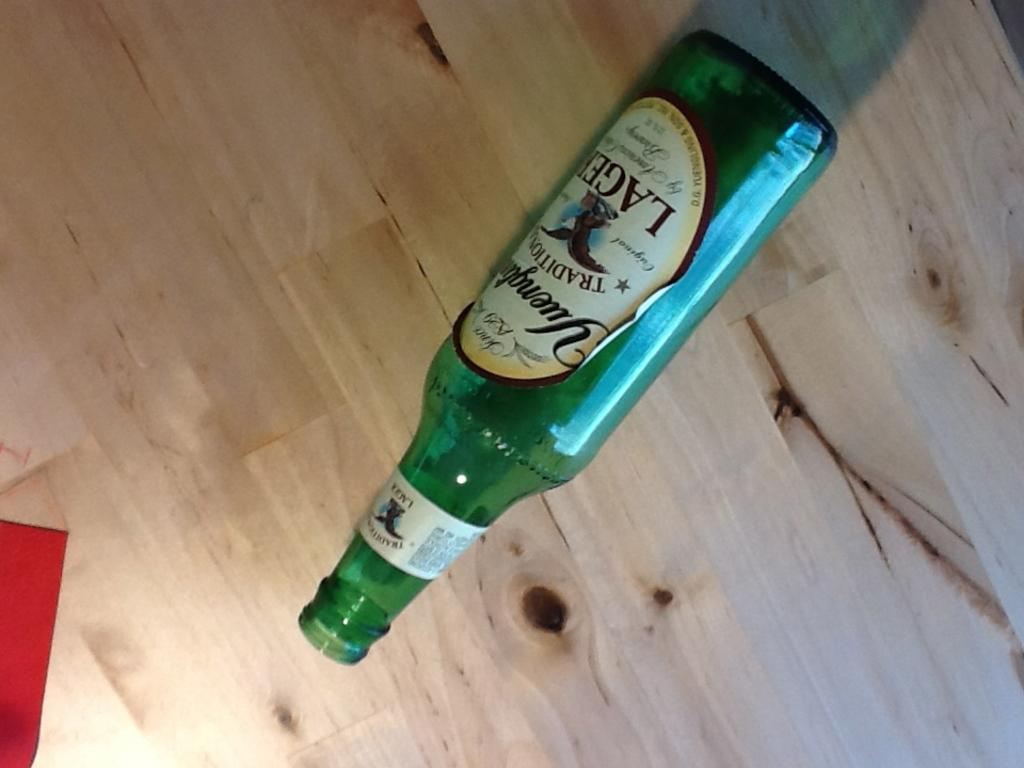<image>
Summarize the visual content of the image. A bottle of Yuengling lager lies sideways on a table. 